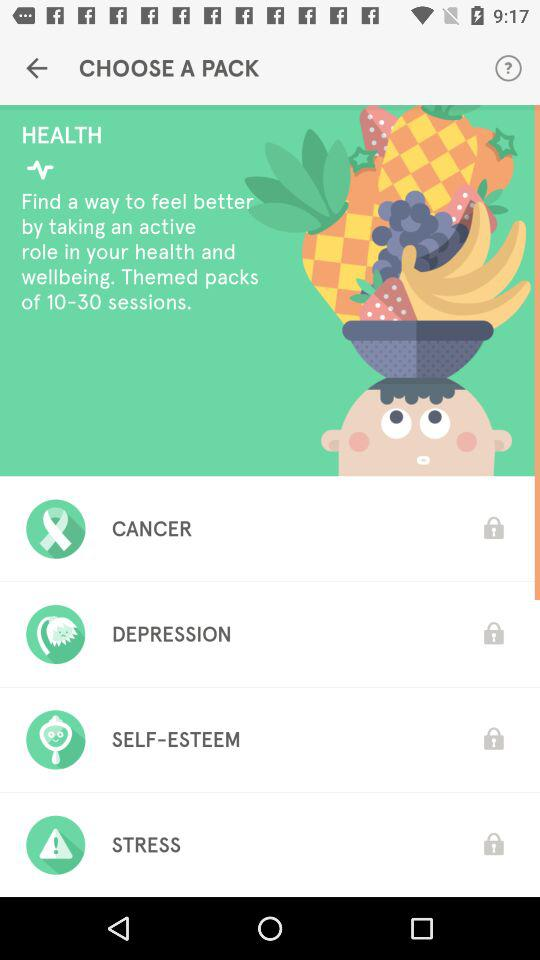How many sessions are available? There are 10 to 30 available sessions. 